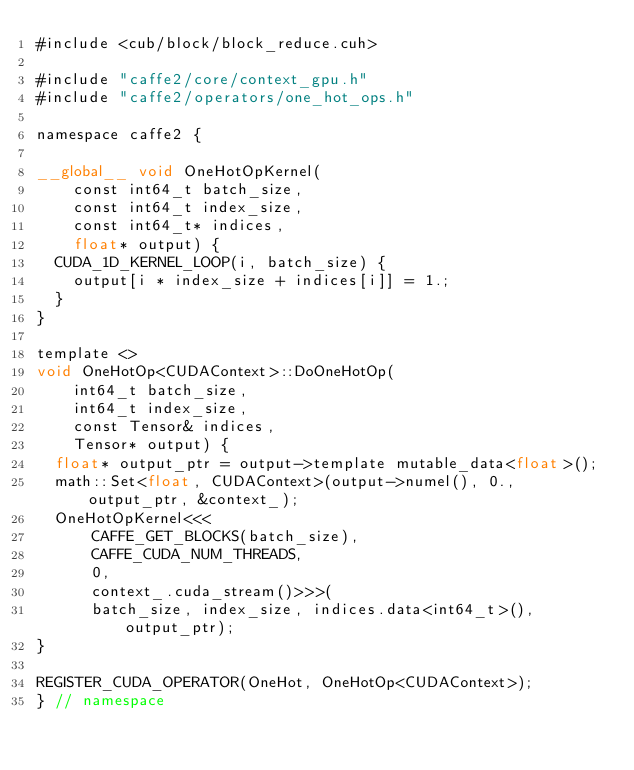<code> <loc_0><loc_0><loc_500><loc_500><_Cuda_>#include <cub/block/block_reduce.cuh>

#include "caffe2/core/context_gpu.h"
#include "caffe2/operators/one_hot_ops.h"

namespace caffe2 {

__global__ void OneHotOpKernel(
    const int64_t batch_size,
    const int64_t index_size,
    const int64_t* indices,
    float* output) {
  CUDA_1D_KERNEL_LOOP(i, batch_size) {
    output[i * index_size + indices[i]] = 1.;
  }
}

template <>
void OneHotOp<CUDAContext>::DoOneHotOp(
    int64_t batch_size,
    int64_t index_size,
    const Tensor& indices,
    Tensor* output) {
  float* output_ptr = output->template mutable_data<float>();
  math::Set<float, CUDAContext>(output->numel(), 0., output_ptr, &context_);
  OneHotOpKernel<<<
      CAFFE_GET_BLOCKS(batch_size),
      CAFFE_CUDA_NUM_THREADS,
      0,
      context_.cuda_stream()>>>(
      batch_size, index_size, indices.data<int64_t>(), output_ptr);
}

REGISTER_CUDA_OPERATOR(OneHot, OneHotOp<CUDAContext>);
} // namespace
</code> 